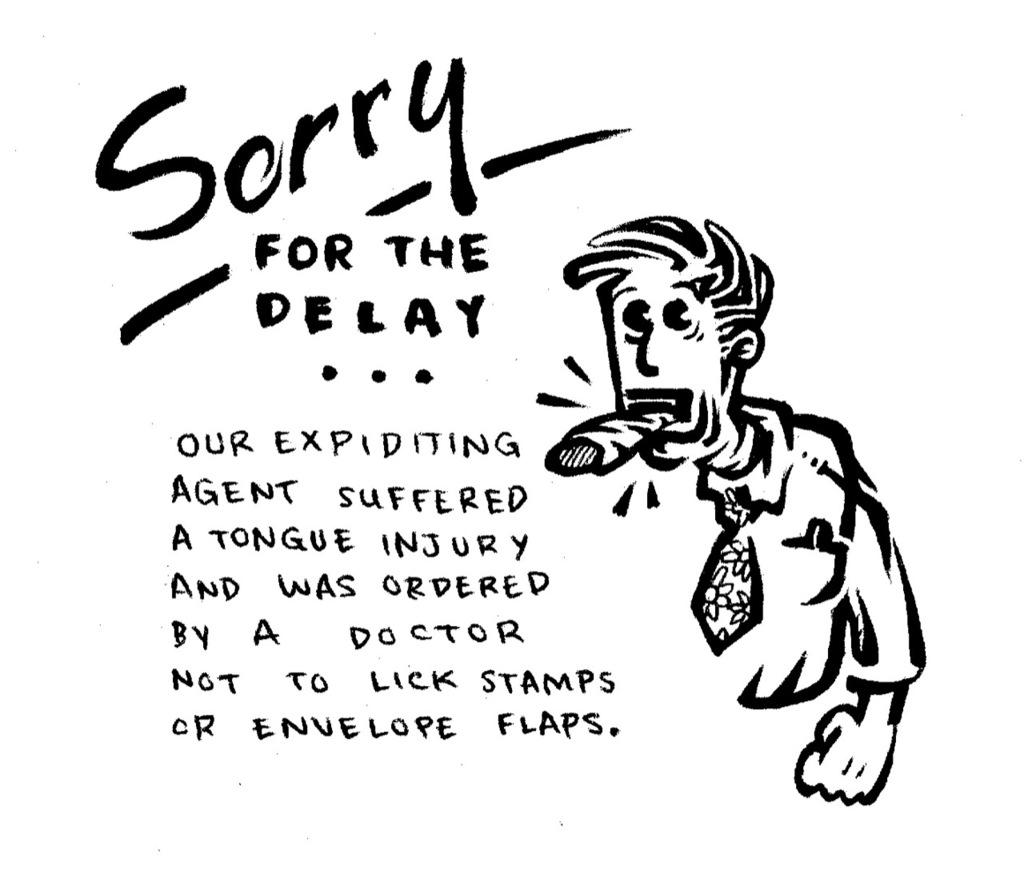What is depicted on the right side of the image? There is a cartoon of a man on the right side of the image. What can be found in the center of the image? There is text in the center of the image. Does the cartoon man have wings in the image? No, the cartoon man does not have wings in the image. What is the purpose of the text in the image? The purpose of the text in the image cannot be determined without additional context or information. 